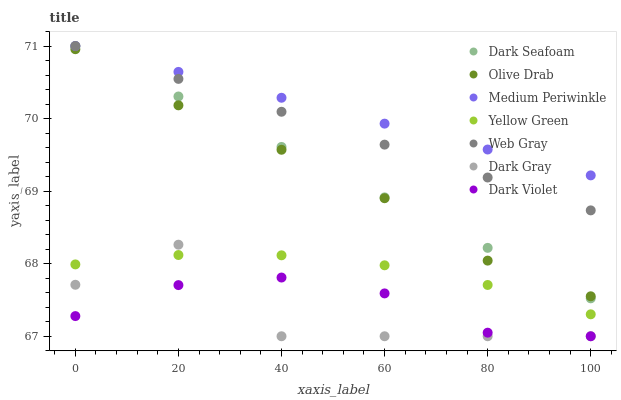Does Dark Gray have the minimum area under the curve?
Answer yes or no. Yes. Does Medium Periwinkle have the maximum area under the curve?
Answer yes or no. Yes. Does Yellow Green have the minimum area under the curve?
Answer yes or no. No. Does Yellow Green have the maximum area under the curve?
Answer yes or no. No. Is Medium Periwinkle the smoothest?
Answer yes or no. Yes. Is Dark Gray the roughest?
Answer yes or no. Yes. Is Yellow Green the smoothest?
Answer yes or no. No. Is Yellow Green the roughest?
Answer yes or no. No. Does Dark Violet have the lowest value?
Answer yes or no. Yes. Does Yellow Green have the lowest value?
Answer yes or no. No. Does Dark Seafoam have the highest value?
Answer yes or no. Yes. Does Yellow Green have the highest value?
Answer yes or no. No. Is Dark Violet less than Olive Drab?
Answer yes or no. Yes. Is Medium Periwinkle greater than Olive Drab?
Answer yes or no. Yes. Does Dark Seafoam intersect Olive Drab?
Answer yes or no. Yes. Is Dark Seafoam less than Olive Drab?
Answer yes or no. No. Is Dark Seafoam greater than Olive Drab?
Answer yes or no. No. Does Dark Violet intersect Olive Drab?
Answer yes or no. No. 